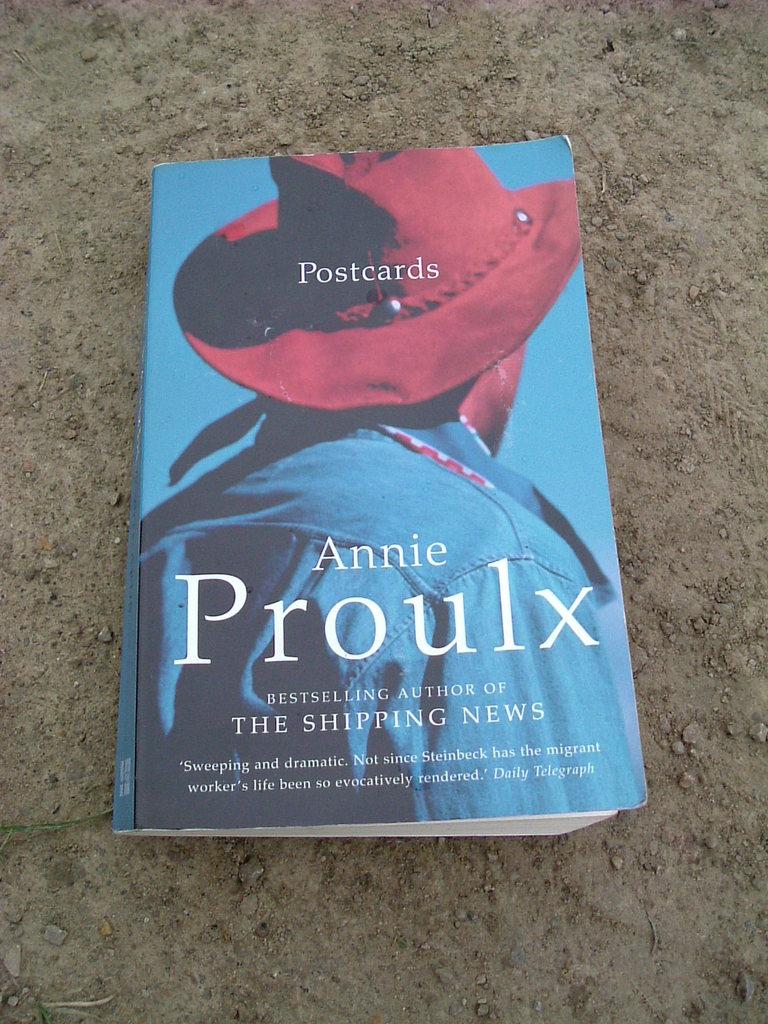Who is the author of the book?
Ensure brevity in your answer.  Annie proulx. What is the name of the book?
Offer a very short reply. Postcards. 